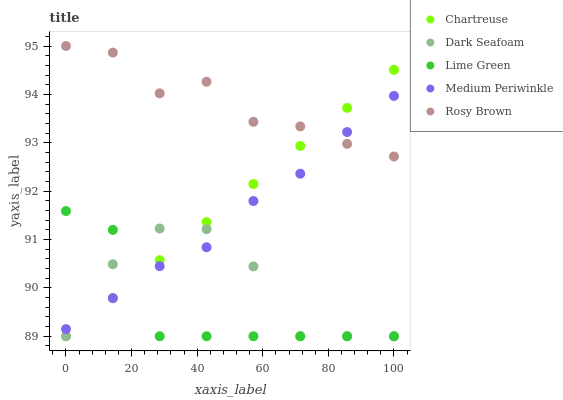Does Lime Green have the minimum area under the curve?
Answer yes or no. Yes. Does Rosy Brown have the maximum area under the curve?
Answer yes or no. Yes. Does Chartreuse have the minimum area under the curve?
Answer yes or no. No. Does Chartreuse have the maximum area under the curve?
Answer yes or no. No. Is Chartreuse the smoothest?
Answer yes or no. Yes. Is Dark Seafoam the roughest?
Answer yes or no. Yes. Is Rosy Brown the smoothest?
Answer yes or no. No. Is Rosy Brown the roughest?
Answer yes or no. No. Does Chartreuse have the lowest value?
Answer yes or no. Yes. Does Rosy Brown have the lowest value?
Answer yes or no. No. Does Rosy Brown have the highest value?
Answer yes or no. Yes. Does Chartreuse have the highest value?
Answer yes or no. No. Is Dark Seafoam less than Rosy Brown?
Answer yes or no. Yes. Is Rosy Brown greater than Lime Green?
Answer yes or no. Yes. Does Chartreuse intersect Rosy Brown?
Answer yes or no. Yes. Is Chartreuse less than Rosy Brown?
Answer yes or no. No. Is Chartreuse greater than Rosy Brown?
Answer yes or no. No. Does Dark Seafoam intersect Rosy Brown?
Answer yes or no. No. 